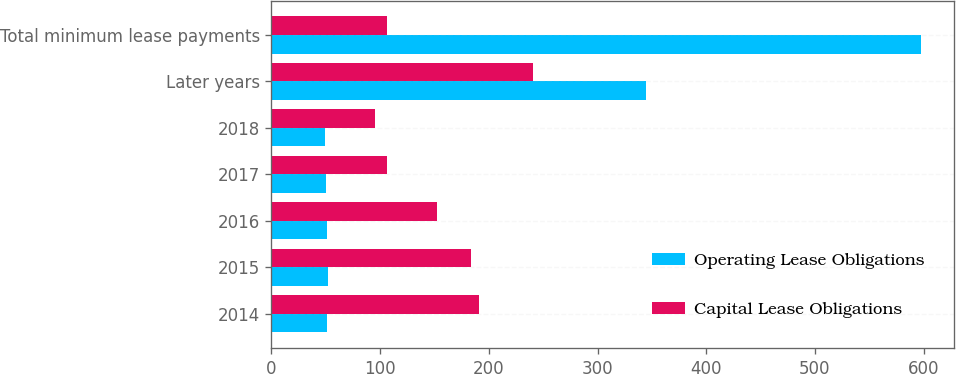<chart> <loc_0><loc_0><loc_500><loc_500><stacked_bar_chart><ecel><fcel>2014<fcel>2015<fcel>2016<fcel>2017<fcel>2018<fcel>Later years<fcel>Total minimum lease payments<nl><fcel>Operating Lease Obligations<fcel>51<fcel>52<fcel>51<fcel>50<fcel>49<fcel>345<fcel>598<nl><fcel>Capital Lease Obligations<fcel>191<fcel>184<fcel>152<fcel>106<fcel>95<fcel>241<fcel>106<nl></chart> 